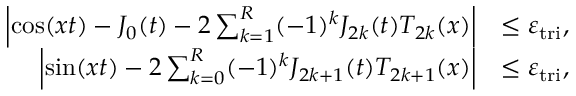<formula> <loc_0><loc_0><loc_500><loc_500>\begin{array} { r l } { \left | \cos ( x t ) - J _ { 0 } ( t ) - 2 \sum _ { k = 1 } ^ { R } ( - 1 ) ^ { k } J _ { 2 k } ( t ) T _ { 2 k } ( x ) \right | } & { \leq \varepsilon _ { t r i } , } \\ { \left | \sin ( x t ) - 2 \sum _ { k = 0 } ^ { R } ( - 1 ) ^ { k } J _ { 2 k + 1 } ( t ) T _ { 2 k + 1 } ( x ) \right | } & { \leq \varepsilon _ { t r i } , } \end{array}</formula> 